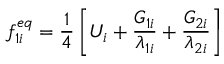Convert formula to latex. <formula><loc_0><loc_0><loc_500><loc_500>f _ { 1 i } ^ { e q } = \frac { 1 } { 4 } \left [ U _ { i } + \frac { G _ { 1 i } } { \lambda _ { 1 i } } + \frac { G _ { 2 i } } { \lambda _ { 2 i } } \right ]</formula> 